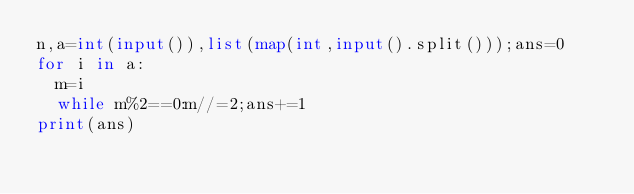Convert code to text. <code><loc_0><loc_0><loc_500><loc_500><_Python_>n,a=int(input()),list(map(int,input().split()));ans=0
for i in a:
  m=i
  while m%2==0:m//=2;ans+=1
print(ans)</code> 